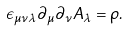Convert formula to latex. <formula><loc_0><loc_0><loc_500><loc_500>\epsilon _ { \mu \nu \lambda } \partial _ { \mu } \partial _ { \nu } A _ { \lambda } = \rho .</formula> 